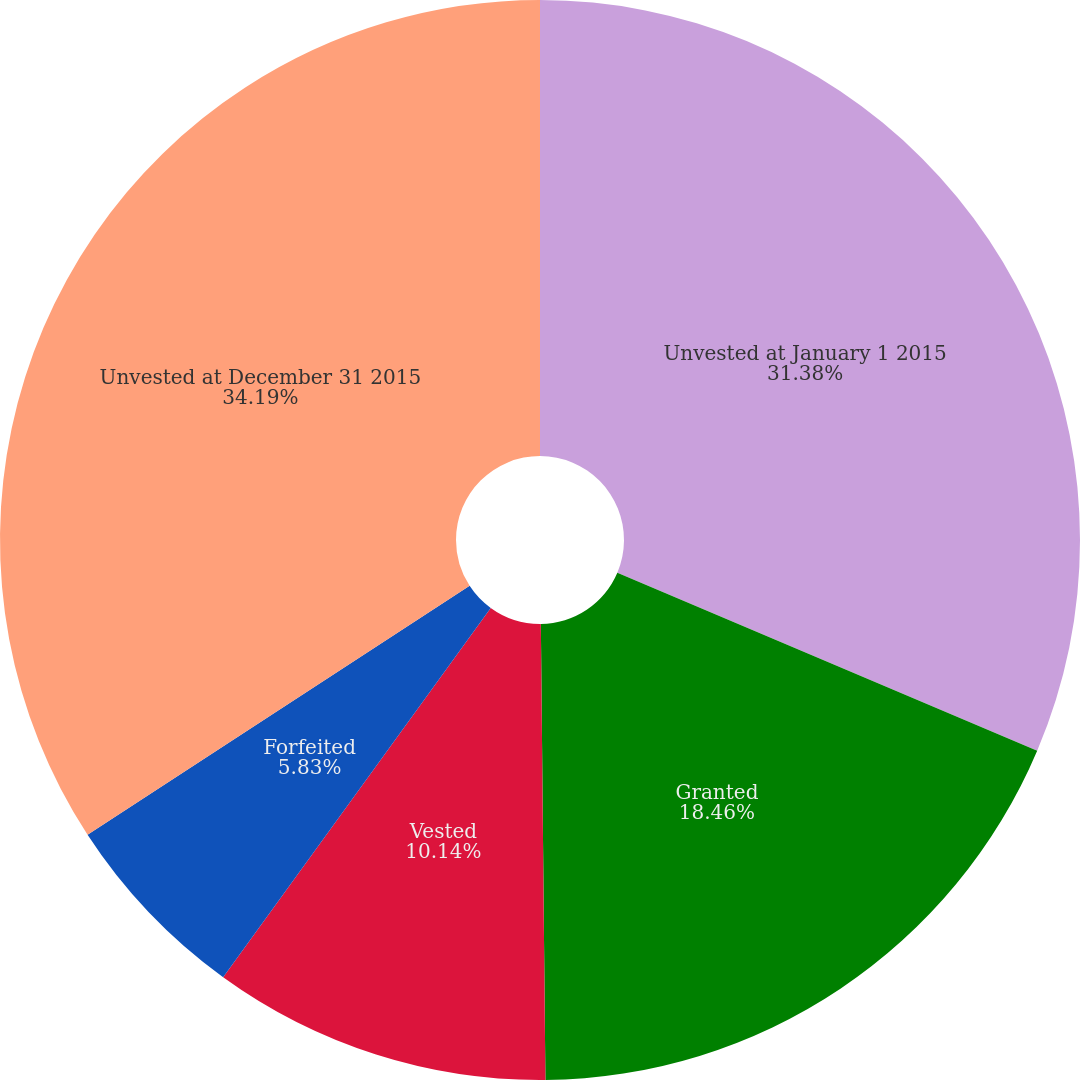<chart> <loc_0><loc_0><loc_500><loc_500><pie_chart><fcel>Unvested at January 1 2015<fcel>Granted<fcel>Vested<fcel>Forfeited<fcel>Unvested at December 31 2015<nl><fcel>31.38%<fcel>18.46%<fcel>10.14%<fcel>5.83%<fcel>34.19%<nl></chart> 